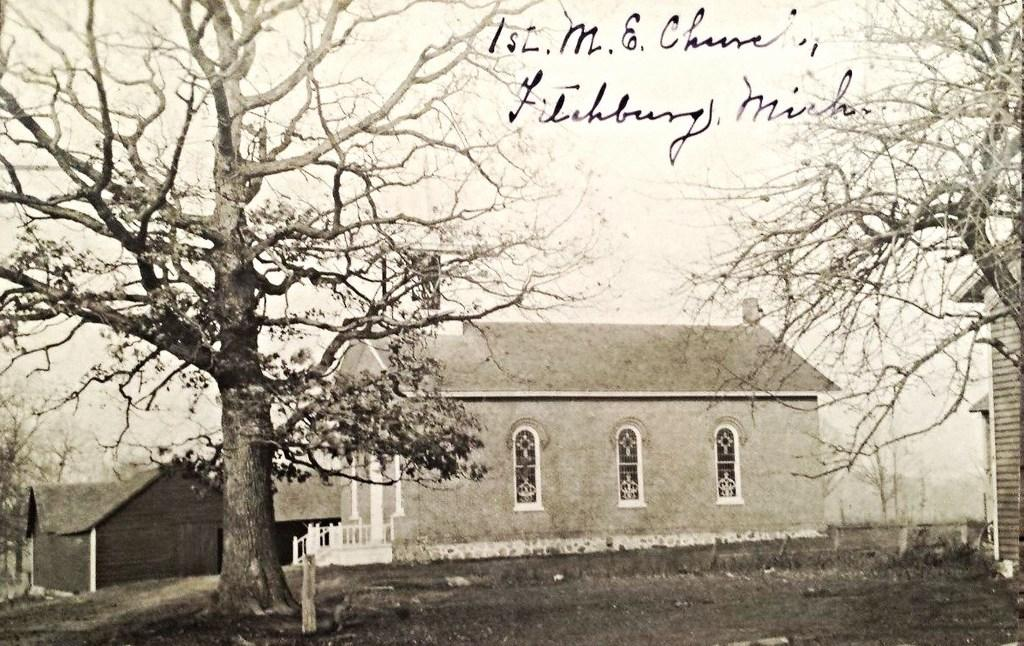What type of structures can be seen in the image? There are houses in the image. What type of vegetation is present on either side of the image? There are trees on either side of the image. What else can be seen in the image besides the houses and trees? There is some text visible on the image. What is visible in the background of the image? There is a sky visible in the background of the image. How many planes are flying in the image? There are no planes visible in the image. What type of card is being used to communicate in the image? There is no card present in the image. 